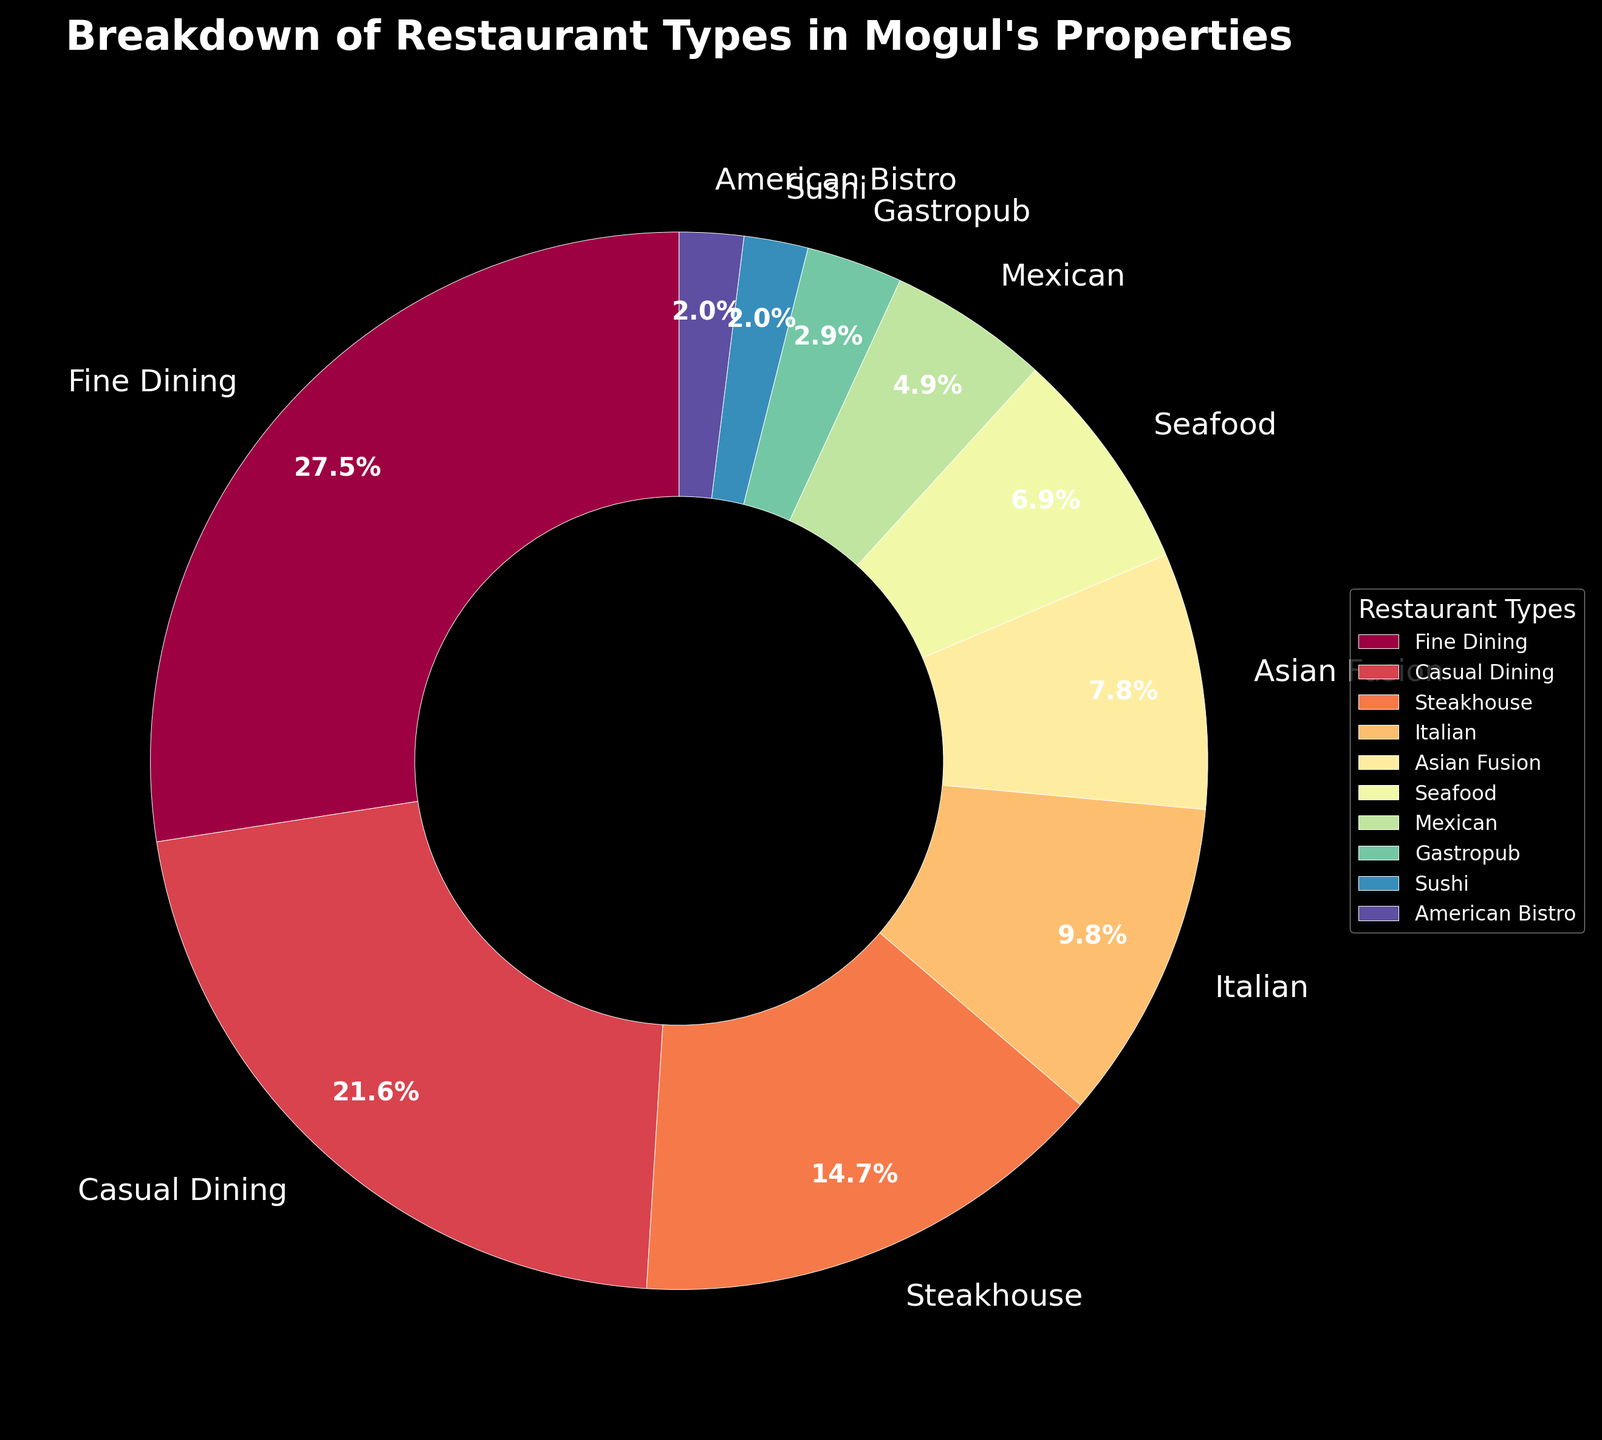Which restaurant type has the largest percentage? The pie chart shows the largest segment representing "Fine Dining" with 28%.
Answer: Fine Dining Which restaurant types have the smallest percentage? The smallest segments in the pie chart are "Sushi" and "American Bistro," both with 2%.
Answer: Sushi and American Bistro What is the total percentage of Asian Fusion, Mexican, and Sushi restaurants combined? Asian Fusion (8%) + Mexican (5%) + Sushi (2%) = 15%.
Answer: 15% How does the percentage of Seafood compare to that of Steakhouse? Seafood has a smaller percentage (7%) compared to Steakhouse (15%).
Answer: Smaller Does the combined percentage of Casual Dining and Fine Dining exceed 50%? If yes, by how much? Casual Dining (22%) + Fine Dining (28%) = 50%, so it equals 50% and does not exceed it.
Answer: No, it equals 50% Among Italian and Asian Fusion, which restaurant type has a higher percentage and by how much? Italian (10%) has a higher percentage compared to Asian Fusion (8%) by 2%.
Answer: Italian by 2% What is the percentage of restaurant types that individually make up less than 10%? Types under 10%: Asian Fusion (8%), Seafood (7%), Mexican (5%), Gastropub (3%), Sushi (2%), and American Bistro (2%), totaling 27%.
Answer: 27% How much greater is the percentage of Casual Dining compared to Mexican? Casual Dining (22%) - Mexican (5%) = 17%.
Answer: 17% If 28% of restaurants are Fine Dining, what fraction of the remaining restaurants are American Bistro? Total of remaining percentages after Fine Dining is 100% - 28% = 72%. American Bistro represents 2% of the total, so the fraction is 2/72 = 1/36.
Answer: 1/36 